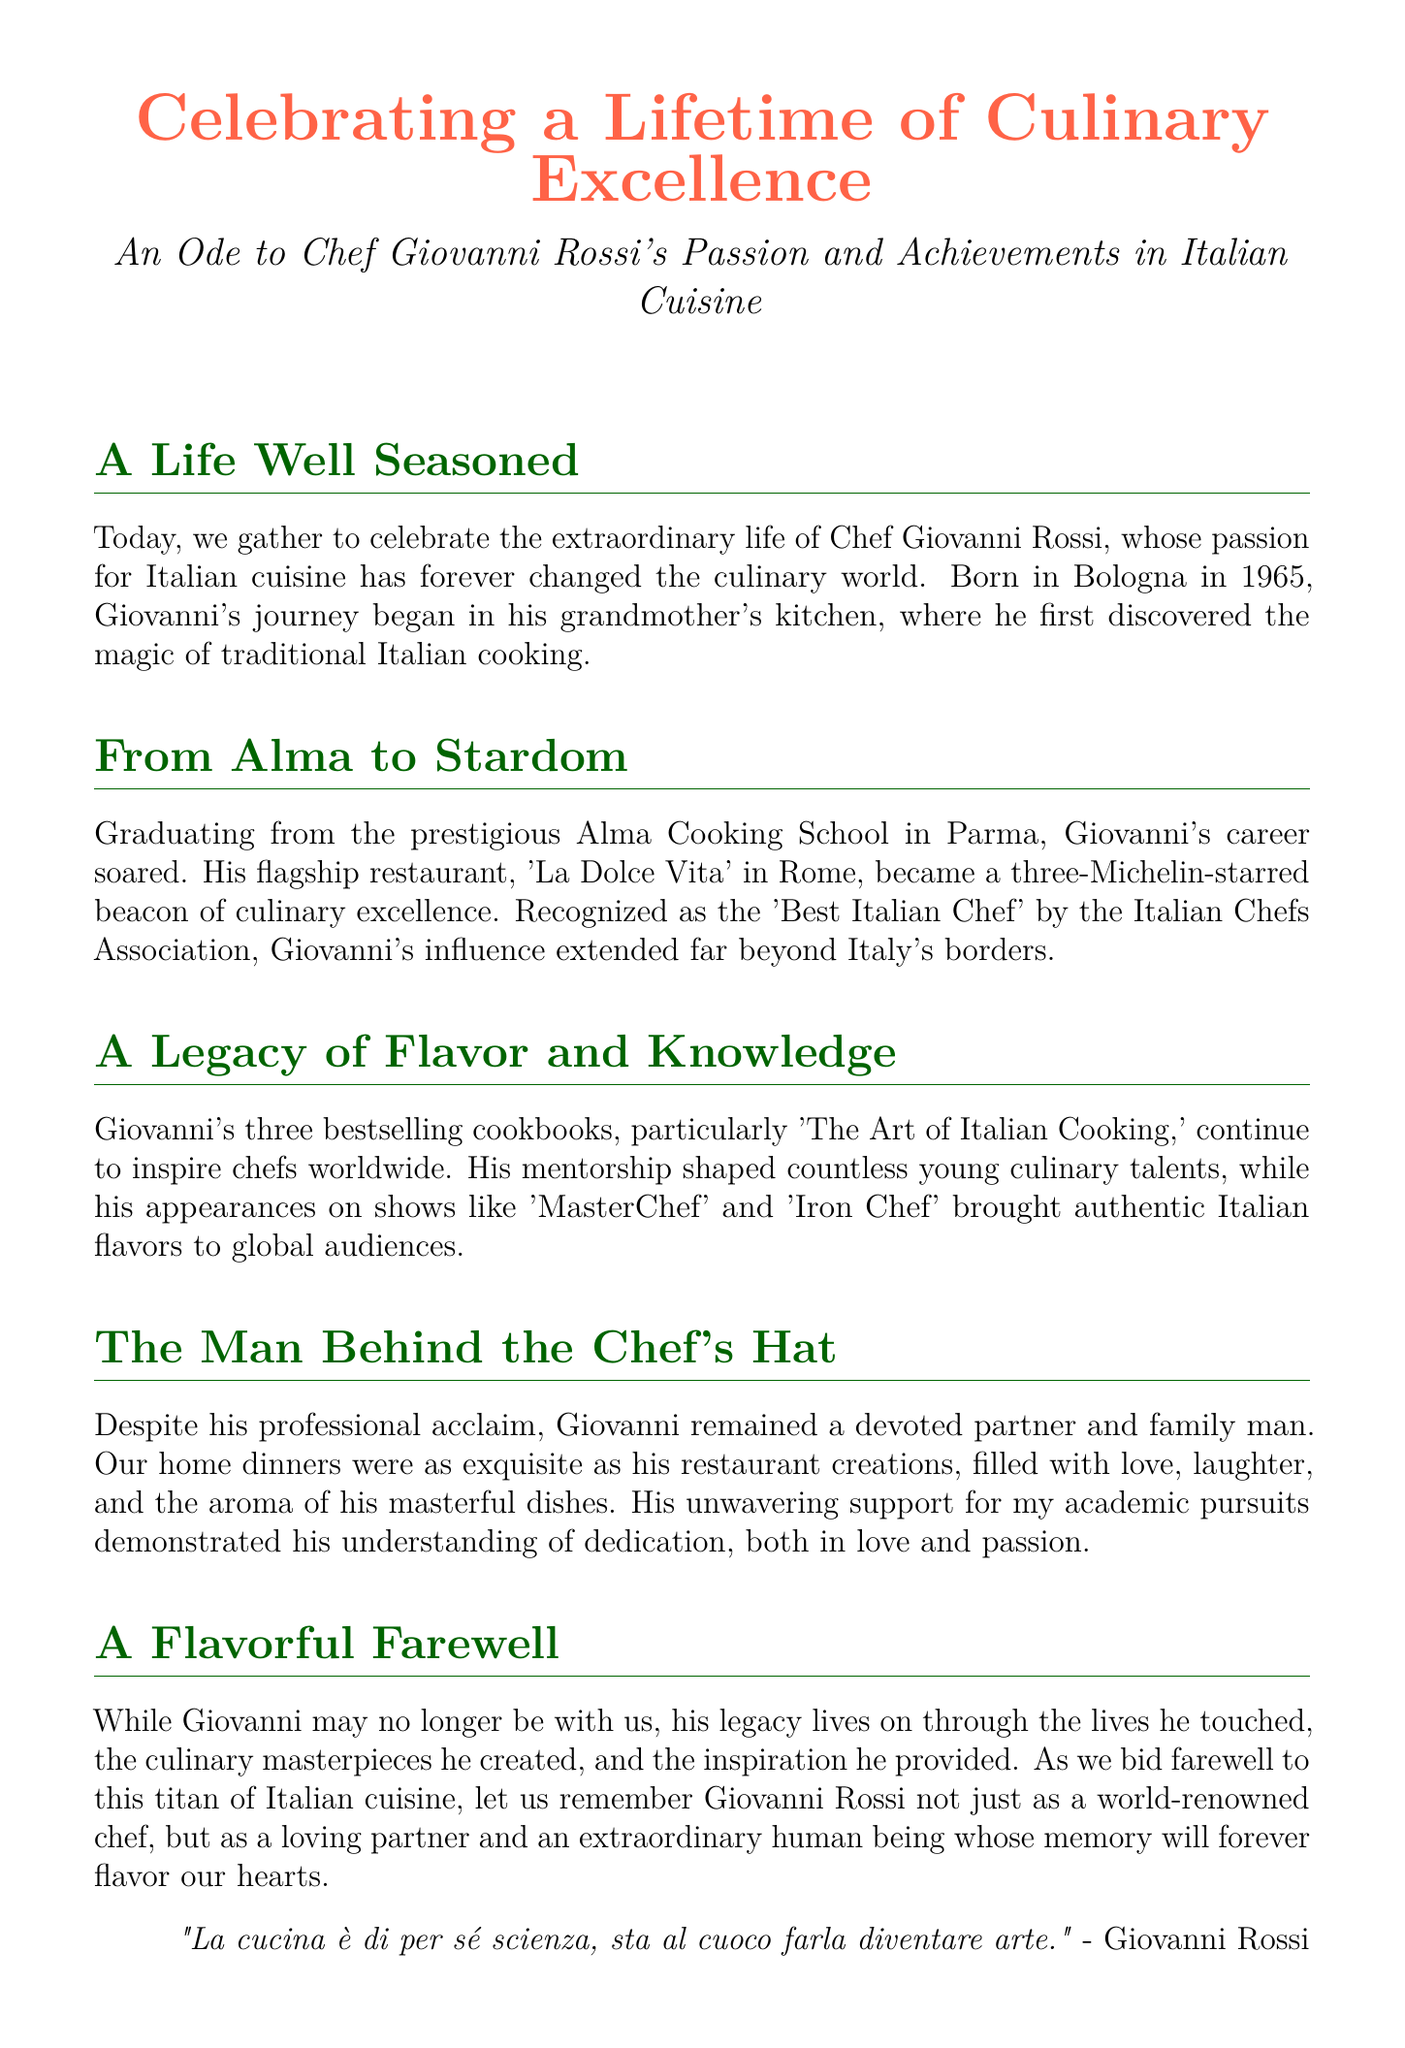What is the name of the chef being honored? The document specifically honors Chef Giovanni Rossi.
Answer: Giovanni Rossi In which city was Giovanni born? The text mentions that Giovanni was born in Bologna.
Answer: Bologna What prestigious cooking school did Giovanni graduate from? The document states he graduated from the Alma Cooking School in Parma.
Answer: Alma Cooking School How many Michelin stars did 'La Dolce Vita' receive? The document indicates that 'La Dolce Vita' became a three-Michelin-starred restaurant.
Answer: Three What is the title of one of Giovanni's bestselling cookbooks? The document references 'The Art of Italian Cooking' as one of his cookbooks.
Answer: The Art of Italian Cooking What kind of shows did Giovanni appear on? It mentions his appearances on 'MasterChef' and 'Iron Chef.'
Answer: Culinary competition shows How did Giovanni demonstrate his understanding of dedication? The text notes his unwavering support for the partner's academic pursuits.
Answer: Support for academic pursuits What phrase reflects Giovanni's view on cooking? The document includes a quote stating "La cucina è di per sé scienza, sta al cuoco farla diventare arte."
Answer: "La cucina è di per sé scienza, sta al cuoco farla diventare arte." What is the theme of the document? The eulogy celebrates culinary excellence and personal dedication.
Answer: Celebrating culinary excellence 